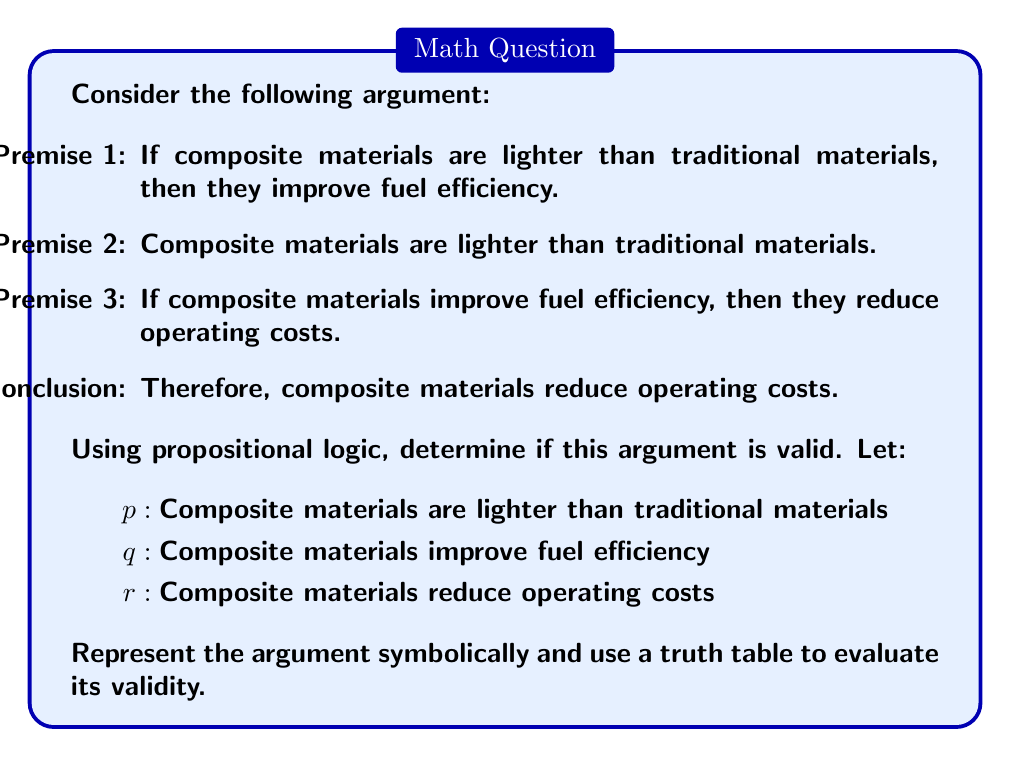What is the answer to this math problem? Let's approach this step-by-step:

1) First, we need to symbolically represent the argument:
   Premise 1: $p \rightarrow q$
   Premise 2: $p$
   Premise 3: $q \rightarrow r$
   Conclusion: $r$

2) The argument structure is:
   $((p \rightarrow q) \land p \land (q \rightarrow r)) \rightarrow r$

3) To determine validity, we need to create a truth table for this compound statement. An argument is valid if the conclusion is true whenever all premises are true.

4) Let's create the truth table:

   $$\begin{array}{cccc|ccccc}
   p & q & r & p\rightarrow q & q\rightarrow r & (p\rightarrow q)\land p & ((p\rightarrow q)\land p)\land(q\rightarrow r) & ((p\rightarrow q)\land p\land(q\rightarrow r))\rightarrow r \\
   \hline
   T & T & T & T & T & T & T & T \\
   T & T & F & T & F & T & F & T \\
   T & F & T & F & T & F & F & T \\
   T & F & F & F & T & F & F & T \\
   F & T & T & T & T & F & F & T \\
   F & T & F & T & F & F & F & T \\
   F & F & T & T & T & F & F & T \\
   F & F & F & T & T & F & F & T \\
   \end{array}$$

5) In the truth table, we're interested in rows where all premises are true. This occurs only in the first row, where $p$, $q$, and $r$ are all true.

6) In this row, we see that the conclusion $r$ is also true.

7) Therefore, whenever all premises are true, the conclusion is also true, which means the argument is valid.
Answer: Valid 